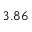Convert formula to latex. <formula><loc_0><loc_0><loc_500><loc_500>3 . 8 6</formula> 